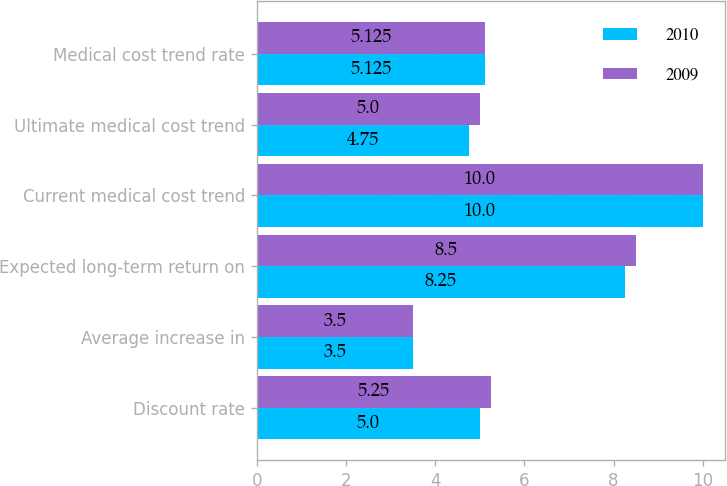Convert chart. <chart><loc_0><loc_0><loc_500><loc_500><stacked_bar_chart><ecel><fcel>Discount rate<fcel>Average increase in<fcel>Expected long-term return on<fcel>Current medical cost trend<fcel>Ultimate medical cost trend<fcel>Medical cost trend rate<nl><fcel>2010<fcel>5<fcel>3.5<fcel>8.25<fcel>10<fcel>4.75<fcel>5.125<nl><fcel>2009<fcel>5.25<fcel>3.5<fcel>8.5<fcel>10<fcel>5<fcel>5.125<nl></chart> 